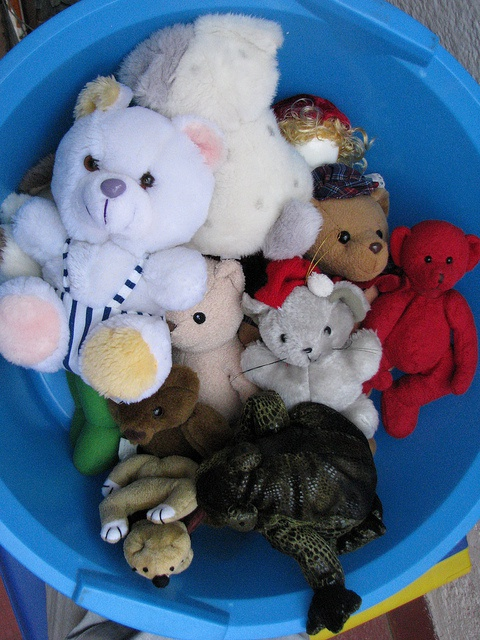Describe the objects in this image and their specific colors. I can see teddy bear in black, lavender, and darkgray tones, teddy bear in black, lightgray, darkgray, and gray tones, teddy bear in black, brown, maroon, and navy tones, teddy bear in black, darkgray, gray, and lightgray tones, and teddy bear in black, darkgray, and gray tones in this image. 